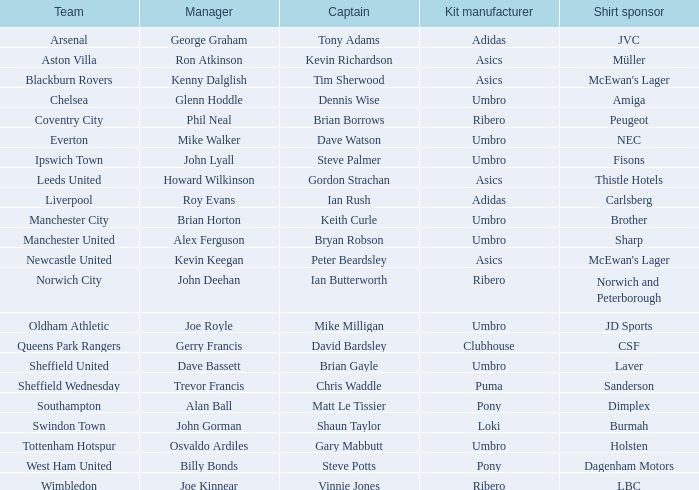What is the kit manufacturer that has billy bonds as the manager? Pony. 